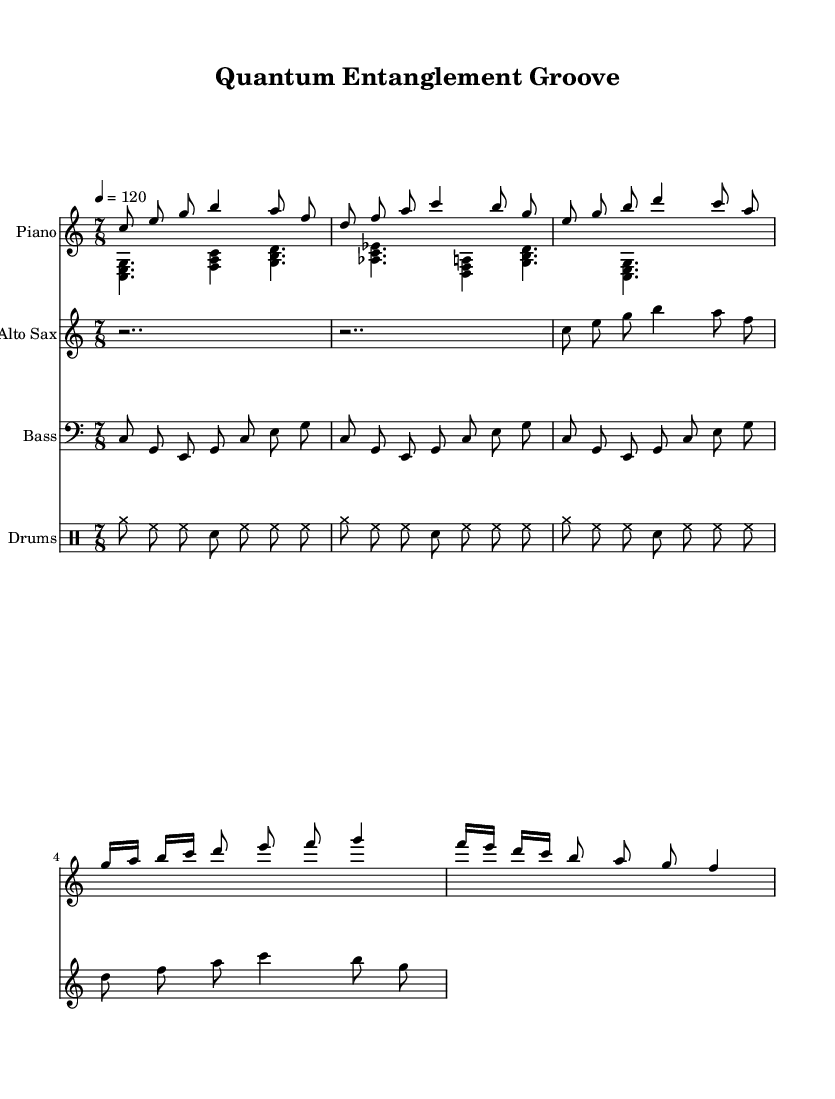What is the time signature of this music? The time signature is indicated at the beginning of the score with the notation in the form of "7/8", which means there are seven eighth notes per measure.
Answer: 7/8 What is the tempo marking for the piece? The tempo marking is given as "4 = 120", which means the quarter note equals 120 beats per minute.
Answer: 120 What instruments are involved in this piece? The instruments are listed in the score header and include Piano, Alto Sax, Bass, and Drums.
Answer: Piano, Alto Sax, Bass, Drums How many measures are shown for the saxophone? By counting the measures from the saxophone staff in the score, we can see that there are four measures present.
Answer: 4 What is the first chord played by the piano left hand? The first chord in the piano left hand is specified as "<c, e g>", which indicates the notes C, E, and G playing together.
Answer: C E G How does the rhythmic pattern of the drums compare to the bass? The drums have a consistent rhythmic pattern with cymbals and snare hits, contrasting with the bass which plays a repetitive eighth-note pattern that emphasizes the root notes.
Answer: Consistent contrasting patterns What defines the avant-garde aspect of this jazz fusion piece? The avant-garde nature can be seen through the unconventional time signature (7/8) and complex phrasing, which pushes traditional jazz boundaries.
Answer: Unconventional time signature 